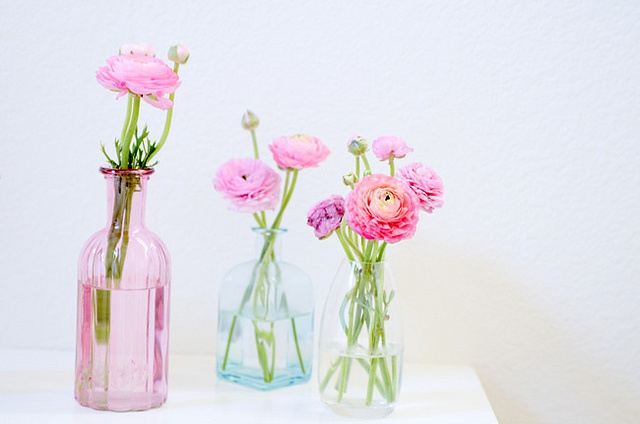Describe the objects in this image and their specific colors. I can see vase in lavender, pink, lightpink, and olive tones, vase in lavender, lightgray, lightgreen, and beige tones, and vase in lavender, lightgray, lightblue, beige, and lightgreen tones in this image. 